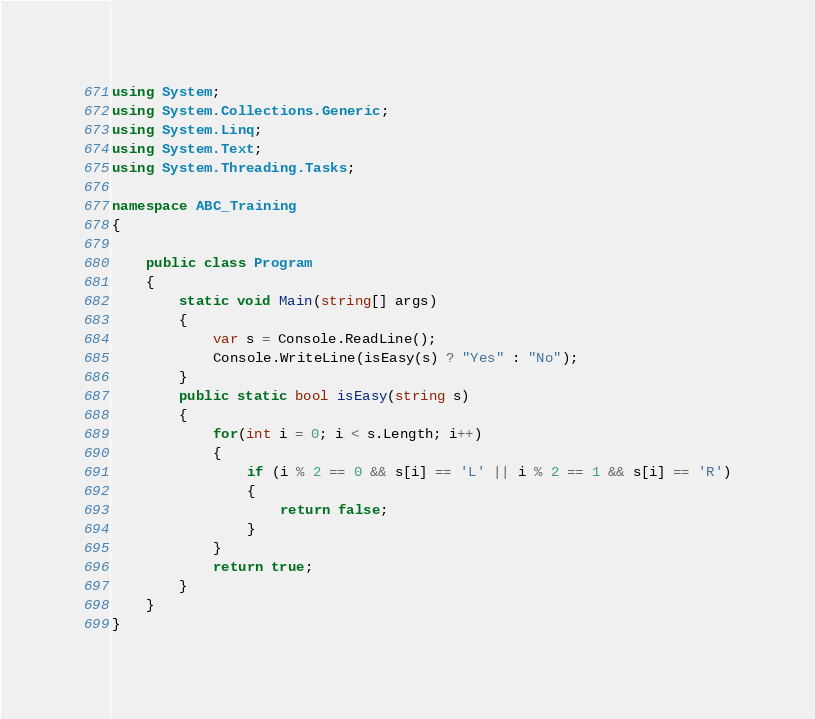Convert code to text. <code><loc_0><loc_0><loc_500><loc_500><_C#_>using System;
using System.Collections.Generic;
using System.Linq;
using System.Text;
using System.Threading.Tasks;

namespace ABC_Training
{

    public class Program
    {
        static void Main(string[] args)
        {
            var s = Console.ReadLine();
            Console.WriteLine(isEasy(s) ? "Yes" : "No");
        }
        public static bool isEasy(string s)
        {
            for(int i = 0; i < s.Length; i++)
            {
                if (i % 2 == 0 && s[i] == 'L' || i % 2 == 1 && s[i] == 'R')
                {
                    return false;
                }
            }
            return true;
        }
    }
}
</code> 